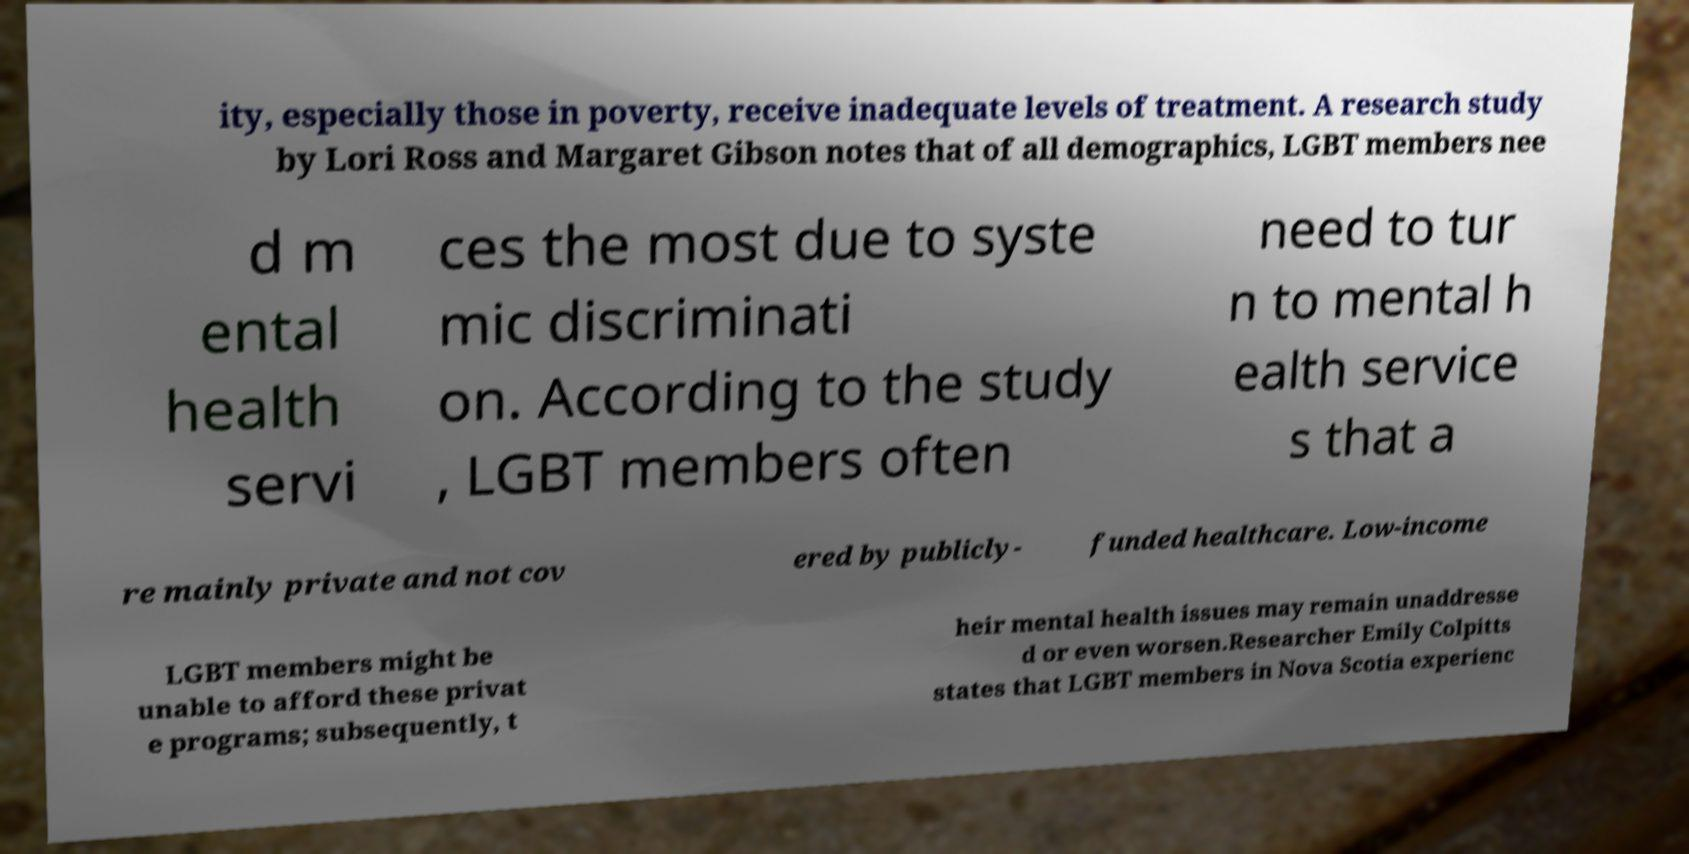What messages or text are displayed in this image? I need them in a readable, typed format. ity, especially those in poverty, receive inadequate levels of treatment. A research study by Lori Ross and Margaret Gibson notes that of all demographics, LGBT members nee d m ental health servi ces the most due to syste mic discriminati on. According to the study , LGBT members often need to tur n to mental h ealth service s that a re mainly private and not cov ered by publicly- funded healthcare. Low-income LGBT members might be unable to afford these privat e programs; subsequently, t heir mental health issues may remain unaddresse d or even worsen.Researcher Emily Colpitts states that LGBT members in Nova Scotia experienc 